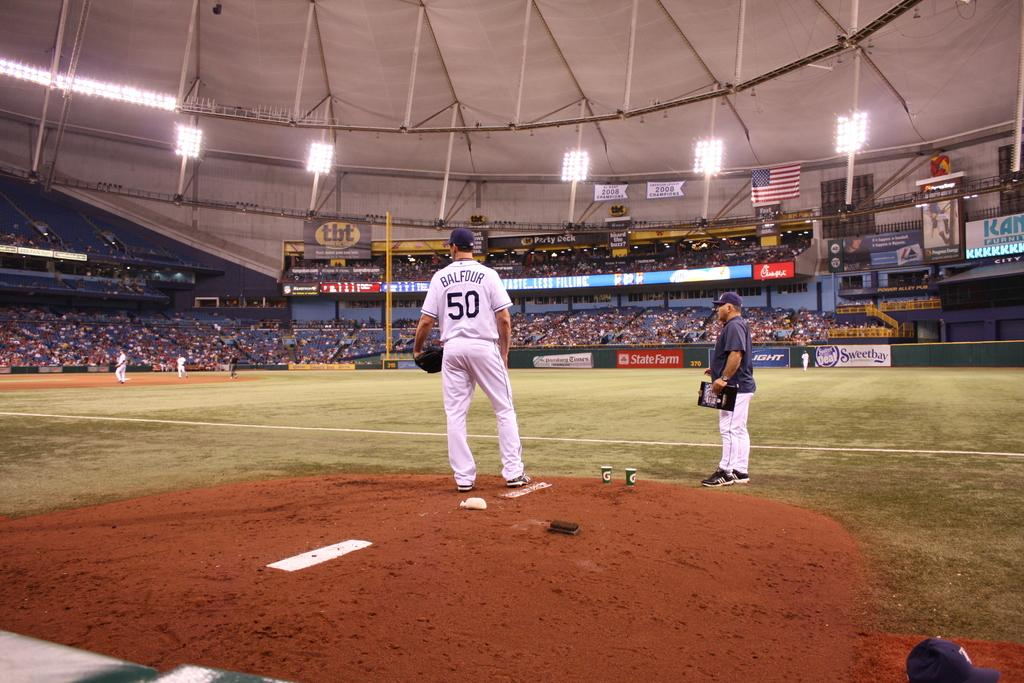Provide a one-sentence caption for the provided image. the baseball player standing in the ground who wear the white jersey printed as BALFOUR and the number 50. 